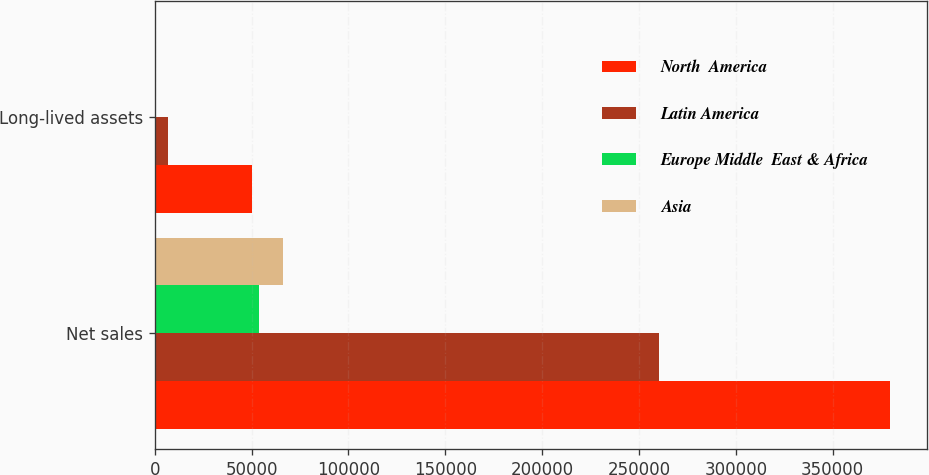<chart> <loc_0><loc_0><loc_500><loc_500><stacked_bar_chart><ecel><fcel>Net sales<fcel>Long-lived assets<nl><fcel>North  America<fcel>379820<fcel>50077<nl><fcel>Latin America<fcel>260125<fcel>6637<nl><fcel>Europe Middle  East & Africa<fcel>53619<fcel>22<nl><fcel>Asia<fcel>65960<fcel>695<nl></chart> 